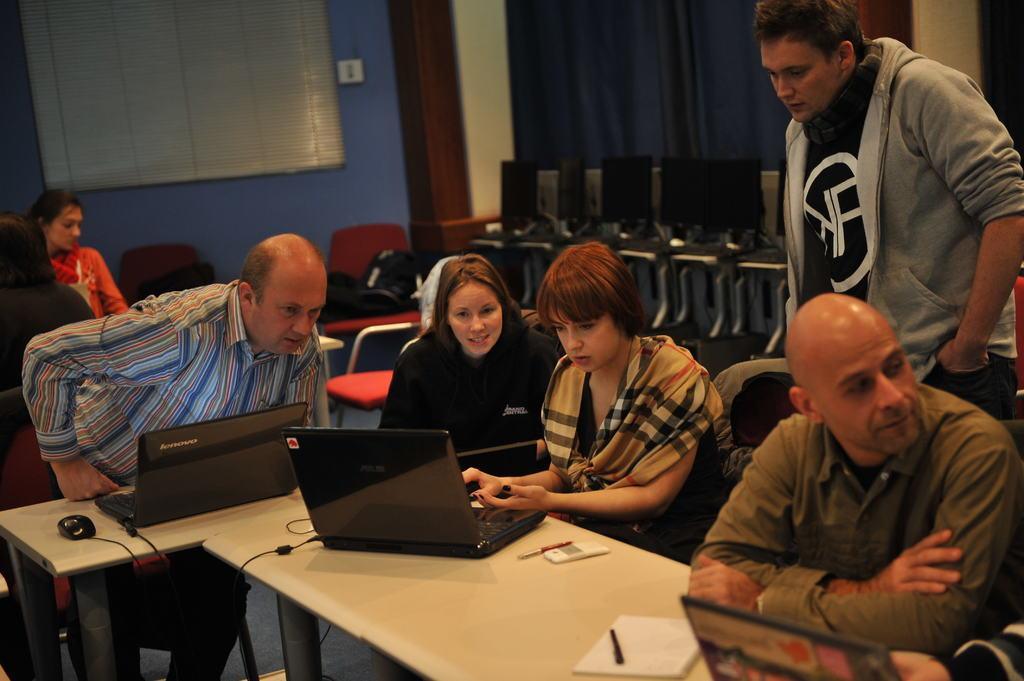How would you summarize this image in a sentence or two? in the picture we can see the room,in which people are sitting and doing some work here we can see the table and chair on the table we can see the laptop,cables,mouse near the persons. 